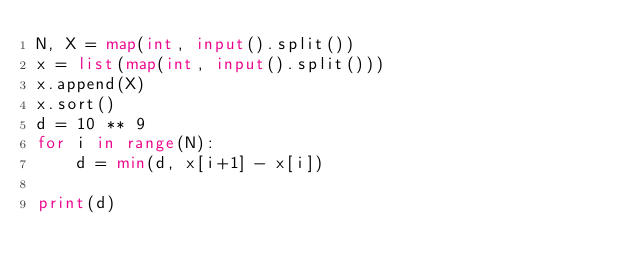<code> <loc_0><loc_0><loc_500><loc_500><_Python_>N, X = map(int, input().split())
x = list(map(int, input().split()))
x.append(X)
x.sort()
d = 10 ** 9
for i in range(N):
    d = min(d, x[i+1] - x[i])

print(d)</code> 